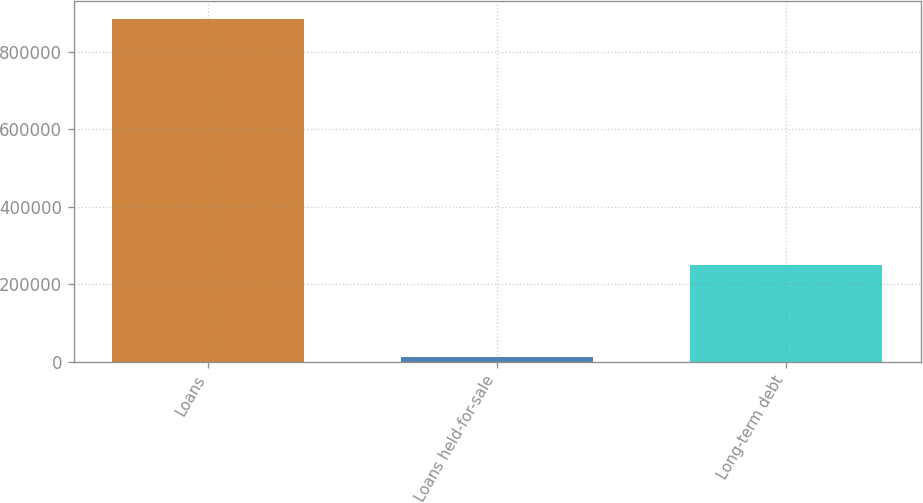<chart> <loc_0><loc_0><loc_500><loc_500><bar_chart><fcel>Loans<fcel>Loans held-for-sale<fcel>Long-term debt<nl><fcel>885724<fcel>11362<fcel>249674<nl></chart> 